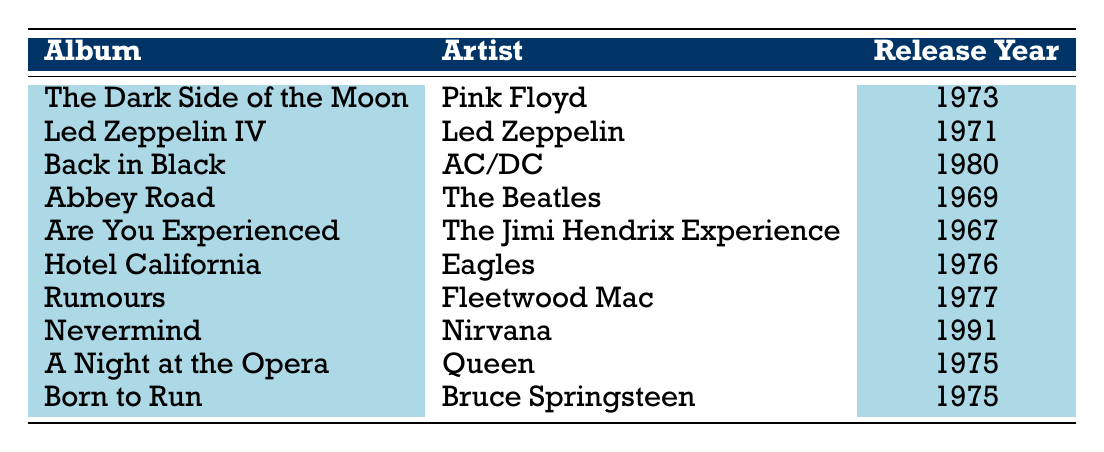What year was "The Dark Side of the Moon" released? The table indicates that "The Dark Side of the Moon" by Pink Floyd was released in the year 1973.
Answer: 1973 Which artist released "Back in Black"? According to the table, "Back in Black" was released by the artist AC/DC.
Answer: AC/DC How many albums were released in the 1970s? By examining the table, the albums released in the 1970s are "Led Zeppelin IV" (1971), "The Dark Side of the Moon" (1973), "Hotel California" (1976), "Rumours" (1977), "A Night at the Opera" (1975), and "Born to Run" (1975). This totals 6 albums.
Answer: 6 Is "Nevermind" by Nirvana released before 1990? The table shows "Nevermind" was released in 1991, which is after 1990. Therefore, the statement is false.
Answer: No What is the difference in release years between "Abbey Road" and "Back in Black"? "Abbey Road" was released in 1969 and "Back in Black" in 1980. The difference is 1980 - 1969 = 11 years.
Answer: 11 Which album has the earliest release year and who is the artist? The earliest release year in the table is 1967 for "Are You Experienced" by The Jimi Hendrix Experience.
Answer: Are You Experienced, The Jimi Hendrix Experience What percentage of the albums listed are by artists from the 60s? The table shows a total of 10 albums, with 2 from the 60s: "Are You Experienced" (1967) and "Abbey Road" (1969). To find the percentage, (2/10)*100 = 20%.
Answer: 20% How many albums were released after 1975? The albums released after 1975 are "Back in Black" (1980) and "Nevermind" (1991), totaling 2 albums.
Answer: 2 Did any album by Fleetwood Mac come out in the 1970s? Yes, the table lists "Rumours" by Fleetwood Mac released in 1977, which confirms the statement is true.
Answer: Yes 